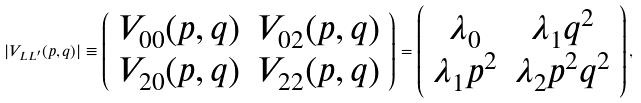<formula> <loc_0><loc_0><loc_500><loc_500>| V _ { L L ^ { \prime } } ( p , q ) | \equiv \left ( \begin{array} { c c } V _ { 0 0 } ( p , q ) & V _ { 0 2 } ( p , q ) \\ V _ { 2 0 } ( p , q ) & V _ { 2 2 } ( p , q ) \\ \end{array} \right ) = \left ( \begin{array} { c c } \lambda _ { 0 } & \lambda _ { 1 } q ^ { 2 } \\ \lambda _ { 1 } p ^ { 2 } & \lambda _ { 2 } p ^ { 2 } q ^ { 2 } \\ \end{array} \right ) ,</formula> 